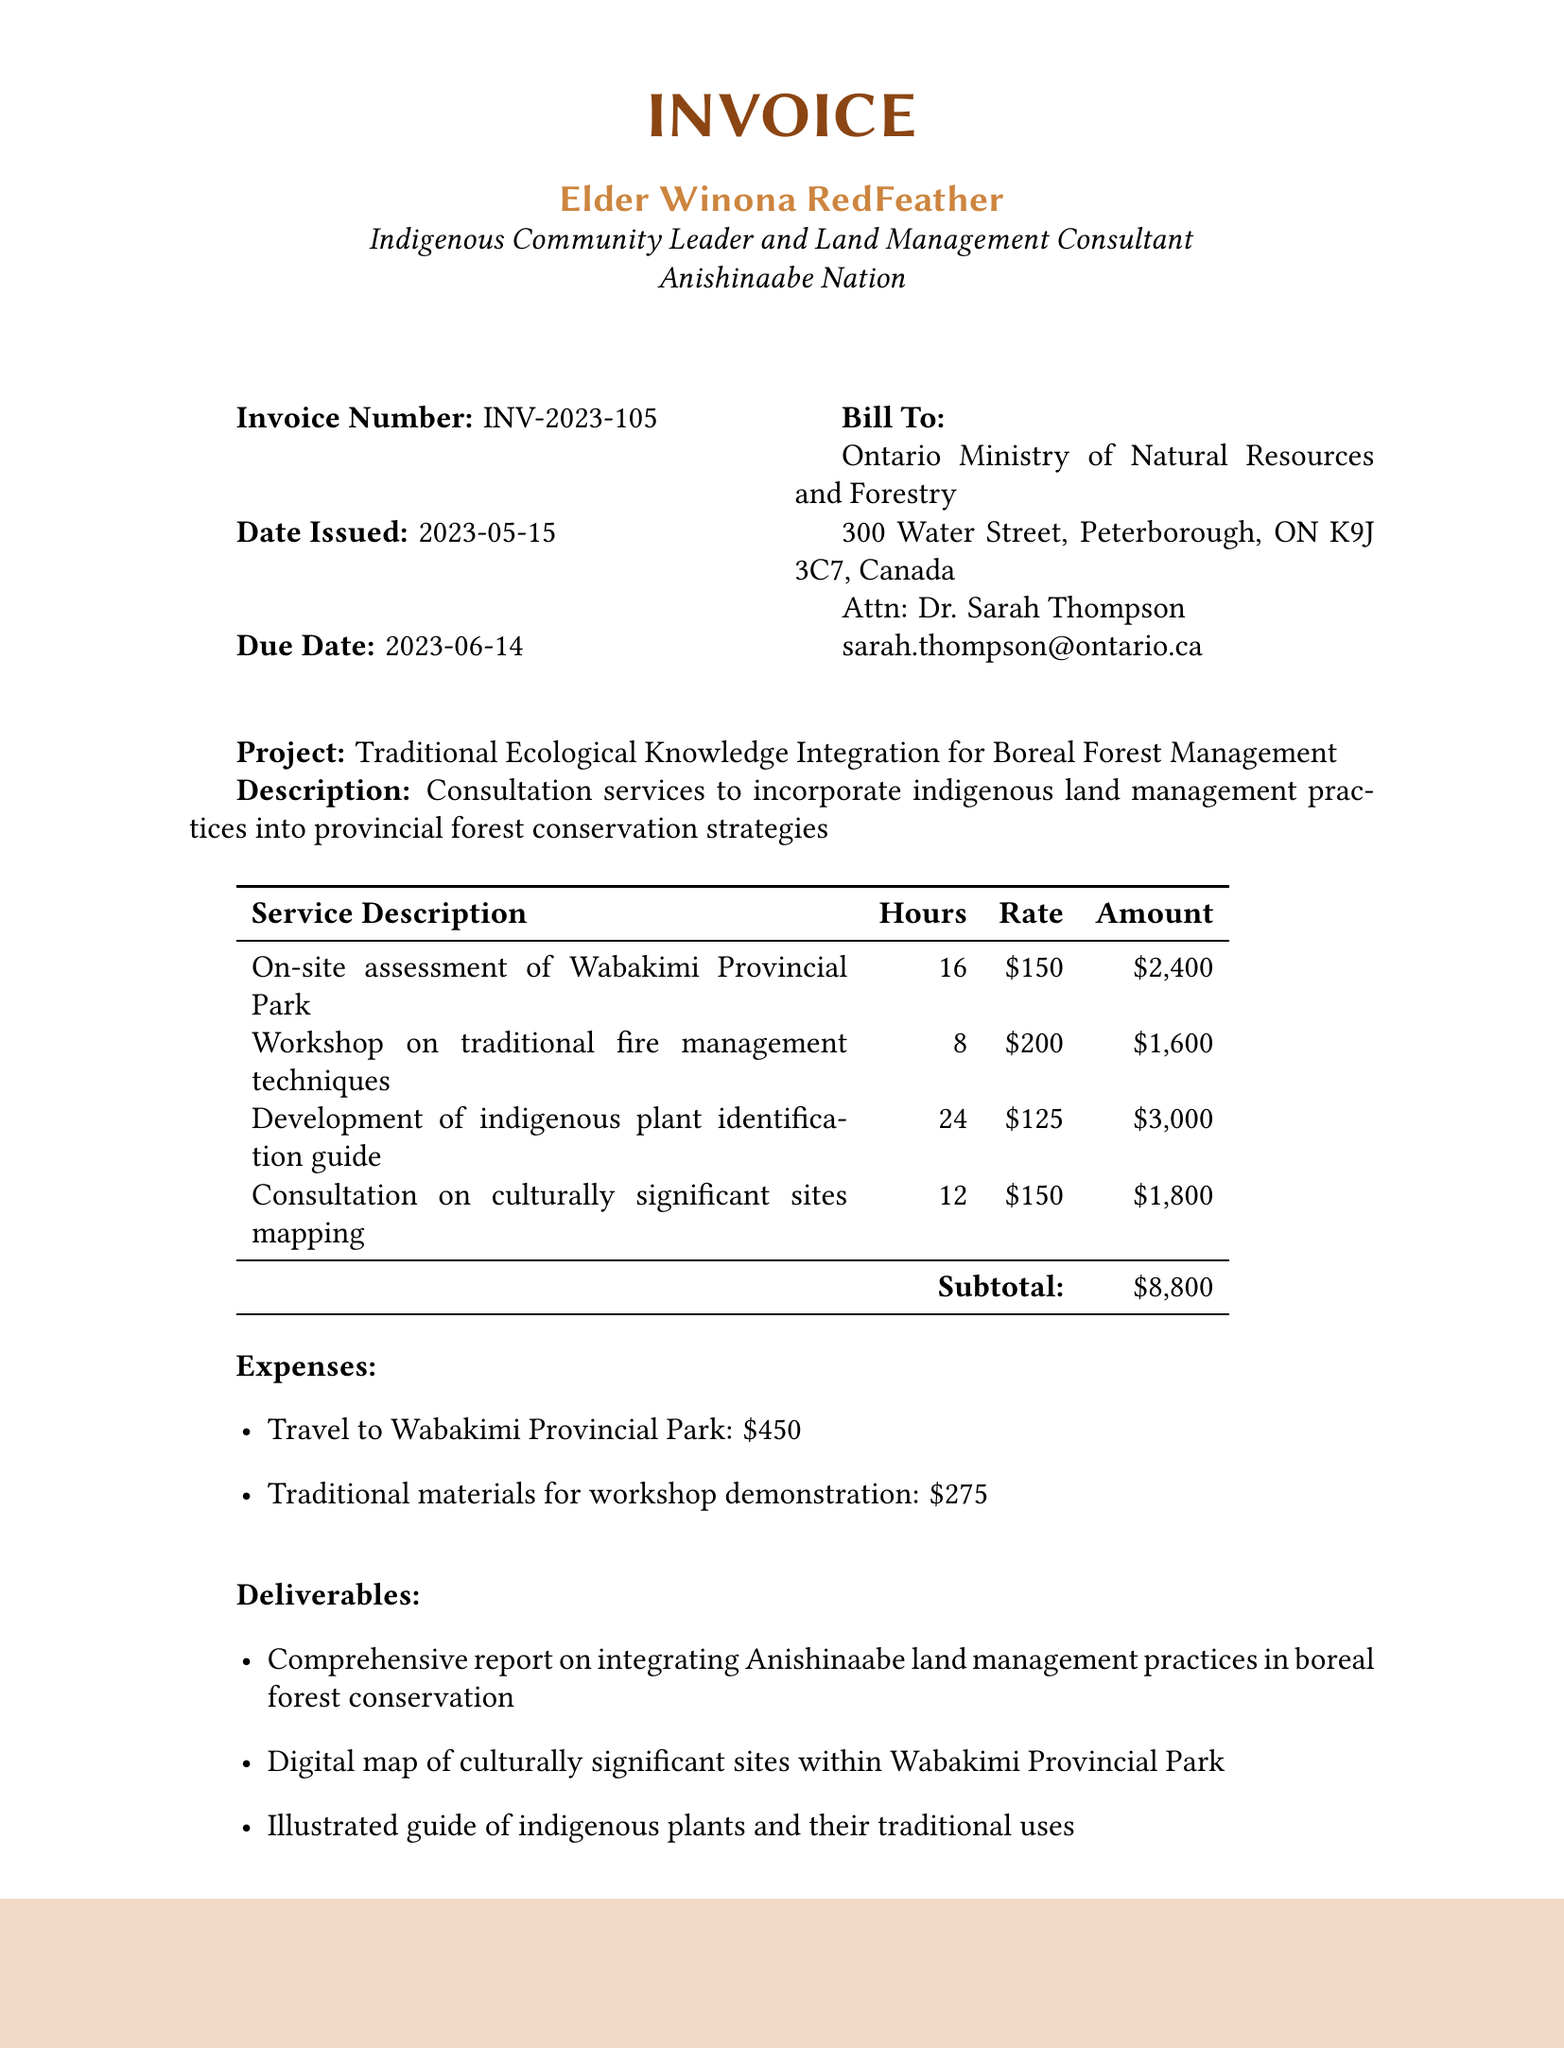What is the invoice number? The invoice number is mentioned at the top of the document, indicating a unique identifier for the invoice.
Answer: INV-2023-105 Who is the service provider? The service provider's name and title are given at the beginning of the document, introducing the individual who provided the services.
Answer: Elder Winona RedFeather What is the due date for the invoice? The due date is specified to indicate when the payment is expected to be made.
Answer: 2023-06-14 How many hours were worked for developing the indigenous plant identification guide? The hours worked for each service are listed in a table format, showing the specific contributions.
Answer: 24 What is the amount for the workshop on traditional fire management techniques? Each service has an associated amount, detailing how much is charged for each listed service provided.
Answer: $1,600 What is the total due for this invoice? The total amount due is calculated at the end, reflecting the comprehensive total that needs to be paid.
Answer: $10,762.45 What is one of the deliverables from this consultation service? The deliverables are listed as outcomes of the consultation, demonstrating what was produced as part of the services.
Answer: Comprehensive report on integrating Anishinaabe land management practices in boreal forest conservation What are the payment instructions for this invoice? The payment instructions section provides information on how and where to make the payment as specified in the invoice.
Answer: First Nations Bank of Canada What is the client’s address? The client’s information, including their address, is provided to ensure proper billing and communication.
Answer: 300 Water Street, Peterborough, ON K9J 3C7, Canada What project is this invoice related to? The project name is highlighted in the document, giving context to the services provided.
Answer: Traditional Ecological Knowledge Integration for Boreal Forest Management 